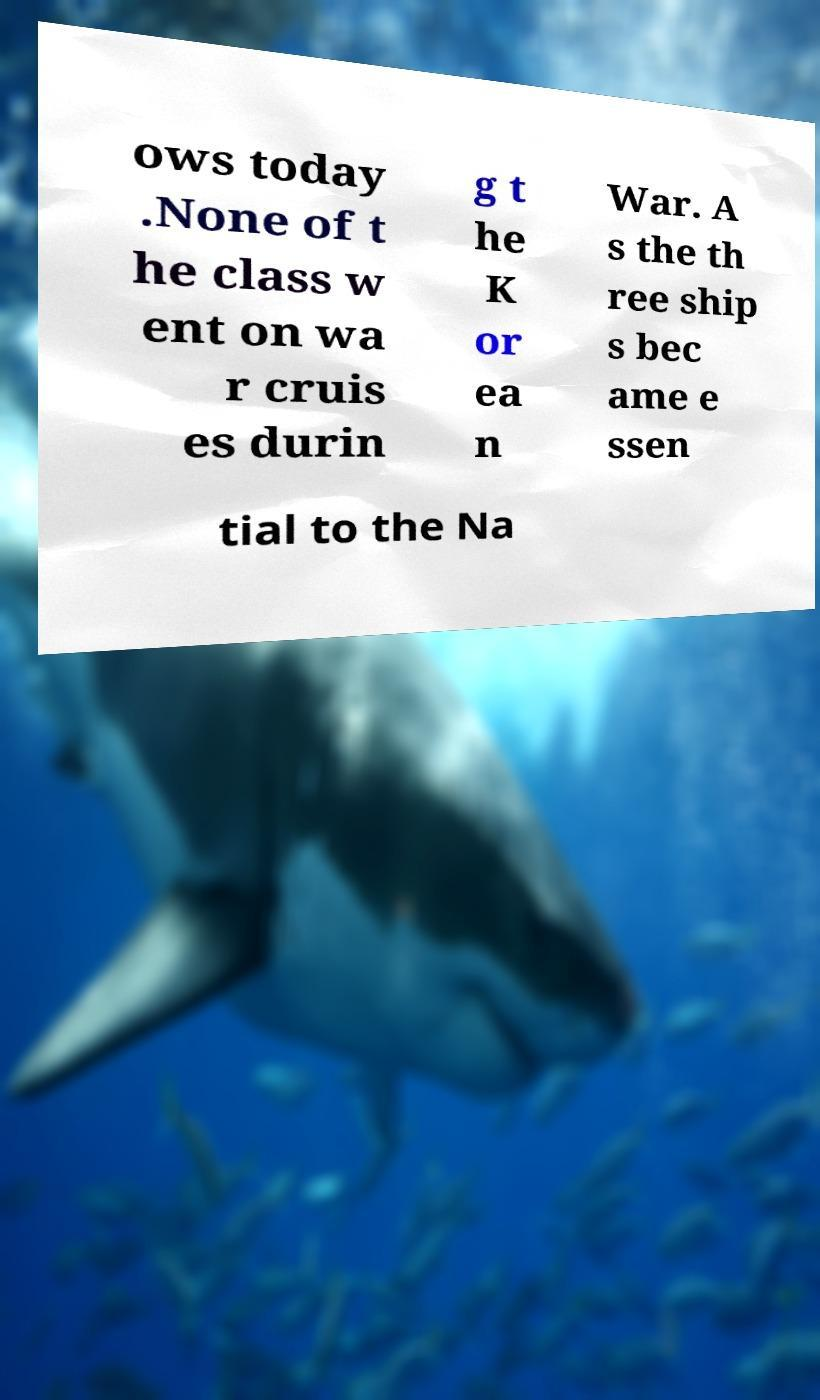What messages or text are displayed in this image? I need them in a readable, typed format. ows today .None of t he class w ent on wa r cruis es durin g t he K or ea n War. A s the th ree ship s bec ame e ssen tial to the Na 